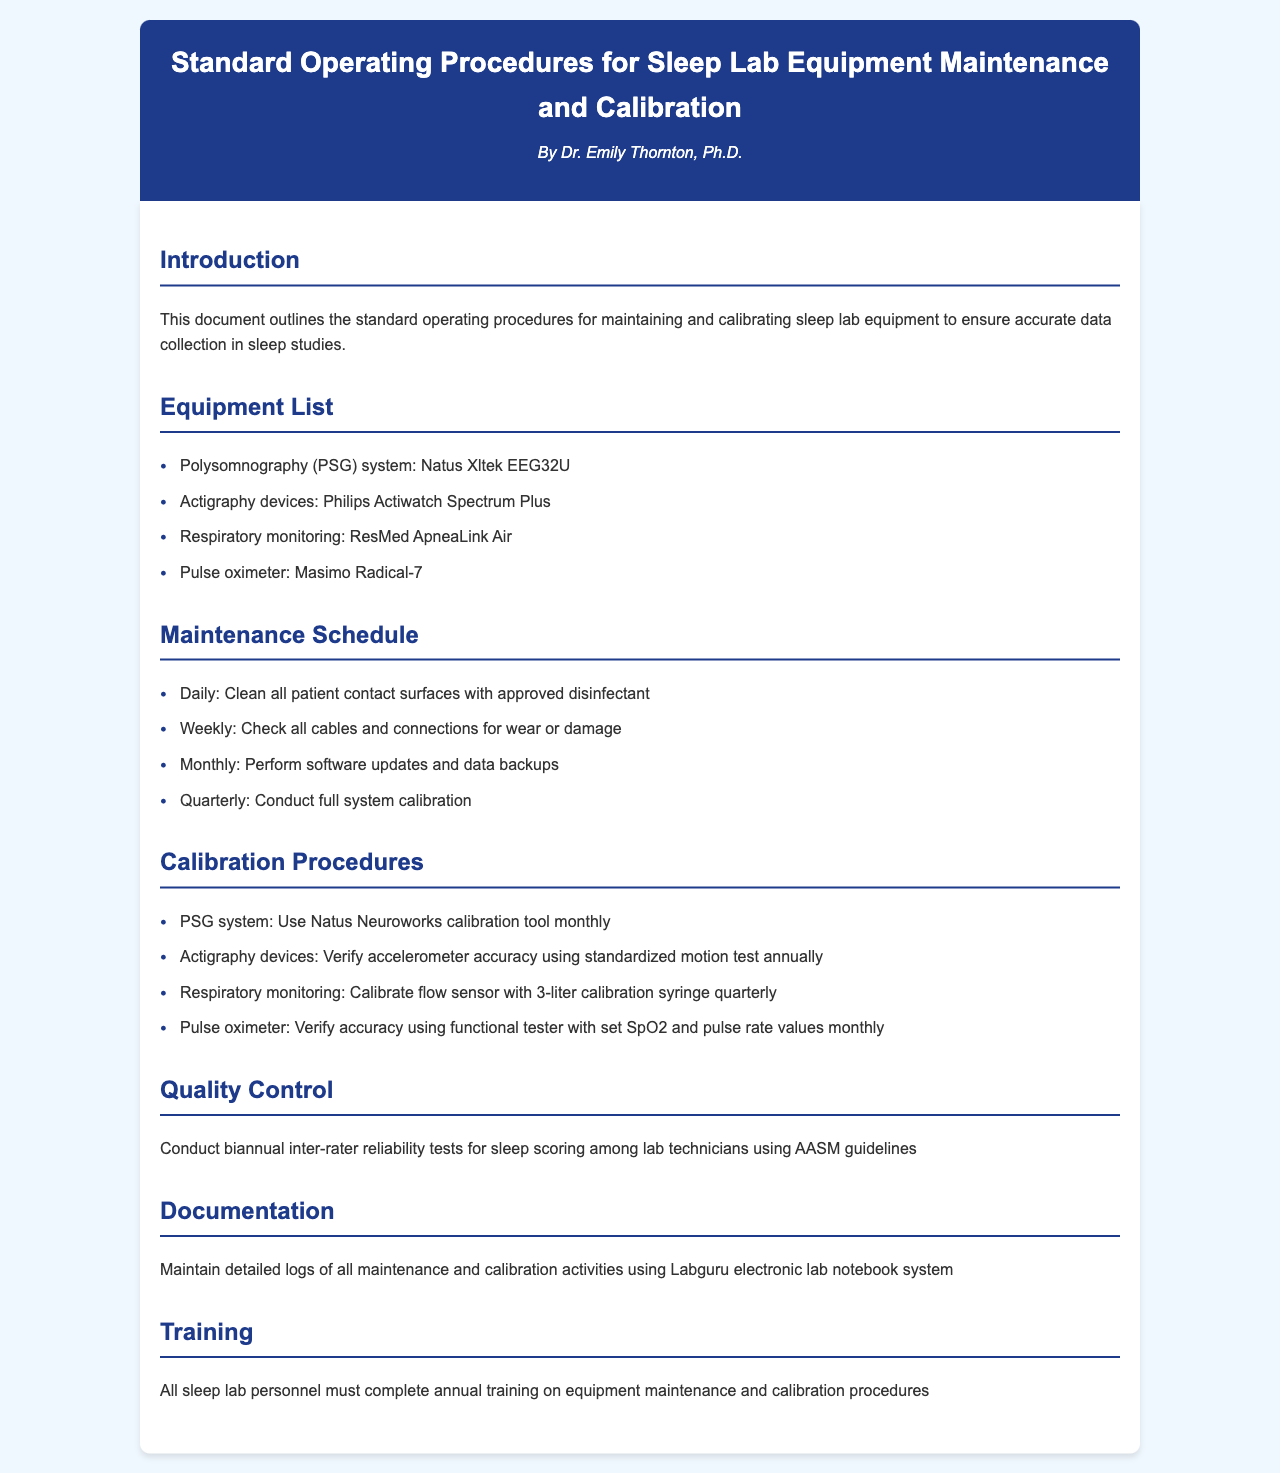What is the title of the document? The title is presented prominently at the top of the document, indicating its focus on procedures for equipment maintenance and calibration.
Answer: Standard Operating Procedures for Sleep Lab Equipment Maintenance and Calibration Who is the author of the document? The author is mentioned in the header section of the document, providing credibility to the procedures outlined.
Answer: Dr. Emily Thornton, Ph.D How often should the PSG system be calibrated? The calibration schedule is listed under the Calibration Procedures section, specifying how frequently this task should be performed.
Answer: Monthly What is the maximum frequency for cleaning patient contact surfaces? The maintenance schedule states that this action should be taken daily for equipment upkeep.
Answer: Daily What tool is used to calibrate the PSG system? The document specifies the tool in the Calibration Procedures section, indicating the equipment to be used for this task.
Answer: Natus Neuroworks calibration tool What is the purpose of the quality control section? The quality control section outlines the importance of ensuring consistent reliability in sleep scoring among lab technicians.
Answer: Inter-rater reliability tests Which electronic system is used for documentation? The documentation section mentions a specific system for maintaining logs of activities, providing clarity on record-keeping.
Answer: Labguru electronic lab notebook system What is the frequency of training for sleep lab personnel? The training guidelines state the necessary frequency for personnel to stay updated on procedures.
Answer: Annual 